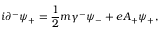Convert formula to latex. <formula><loc_0><loc_0><loc_500><loc_500>i { \partial } ^ { - } { \psi } _ { + } = \frac { 1 } { 2 } m { \gamma } ^ { - } { \psi } _ { - } + e A _ { + } { \psi } _ { + } ,</formula> 